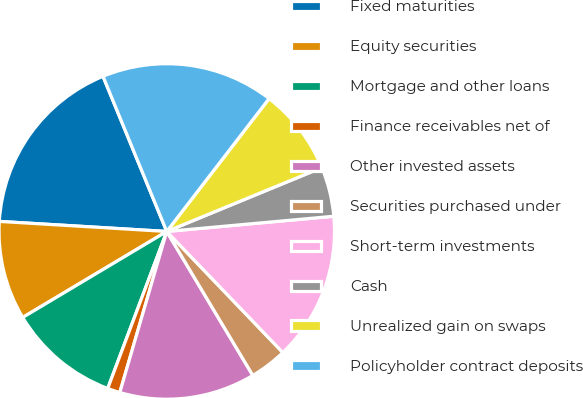Convert chart. <chart><loc_0><loc_0><loc_500><loc_500><pie_chart><fcel>Fixed maturities<fcel>Equity securities<fcel>Mortgage and other loans<fcel>Finance receivables net of<fcel>Other invested assets<fcel>Securities purchased under<fcel>Short-term investments<fcel>Cash<fcel>Unrealized gain on swaps<fcel>Policyholder contract deposits<nl><fcel>17.84%<fcel>9.52%<fcel>10.71%<fcel>1.21%<fcel>13.09%<fcel>3.59%<fcel>14.28%<fcel>4.77%<fcel>8.34%<fcel>16.65%<nl></chart> 